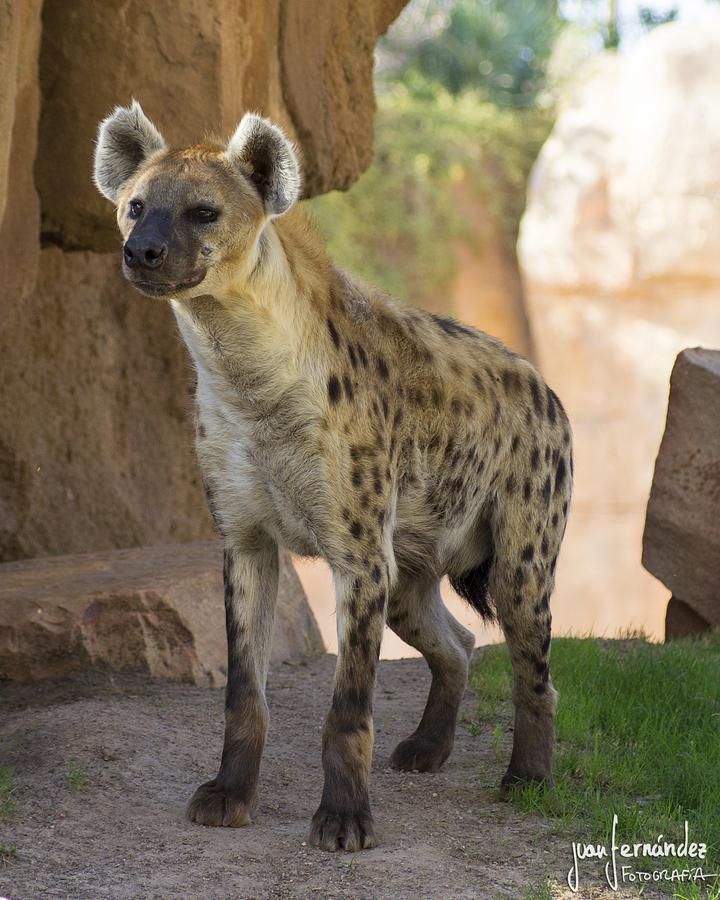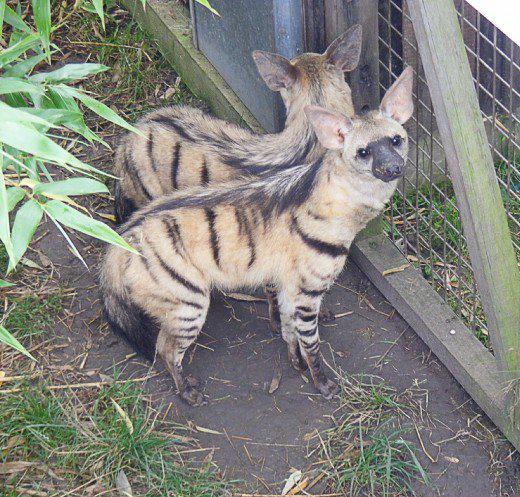The first image is the image on the left, the second image is the image on the right. Considering the images on both sides, is "Each picture has exactly one hyena." valid? Answer yes or no. No. The first image is the image on the left, the second image is the image on the right. For the images displayed, is the sentence "There is at most two hyenas." factually correct? Answer yes or no. No. 